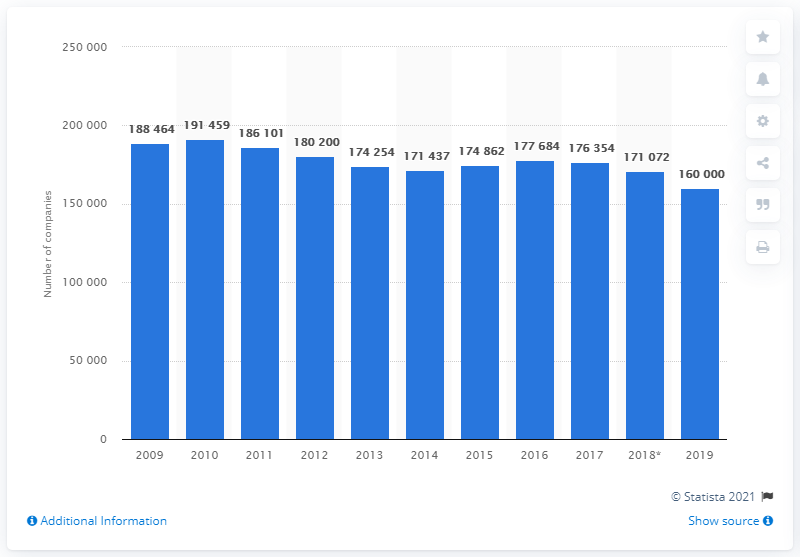Specify some key components in this picture. In 2019, there were approximately 160,000 textile and clothing manufacturers in the world. 